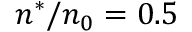Convert formula to latex. <formula><loc_0><loc_0><loc_500><loc_500>n ^ { * } / n _ { 0 } = 0 . 5</formula> 